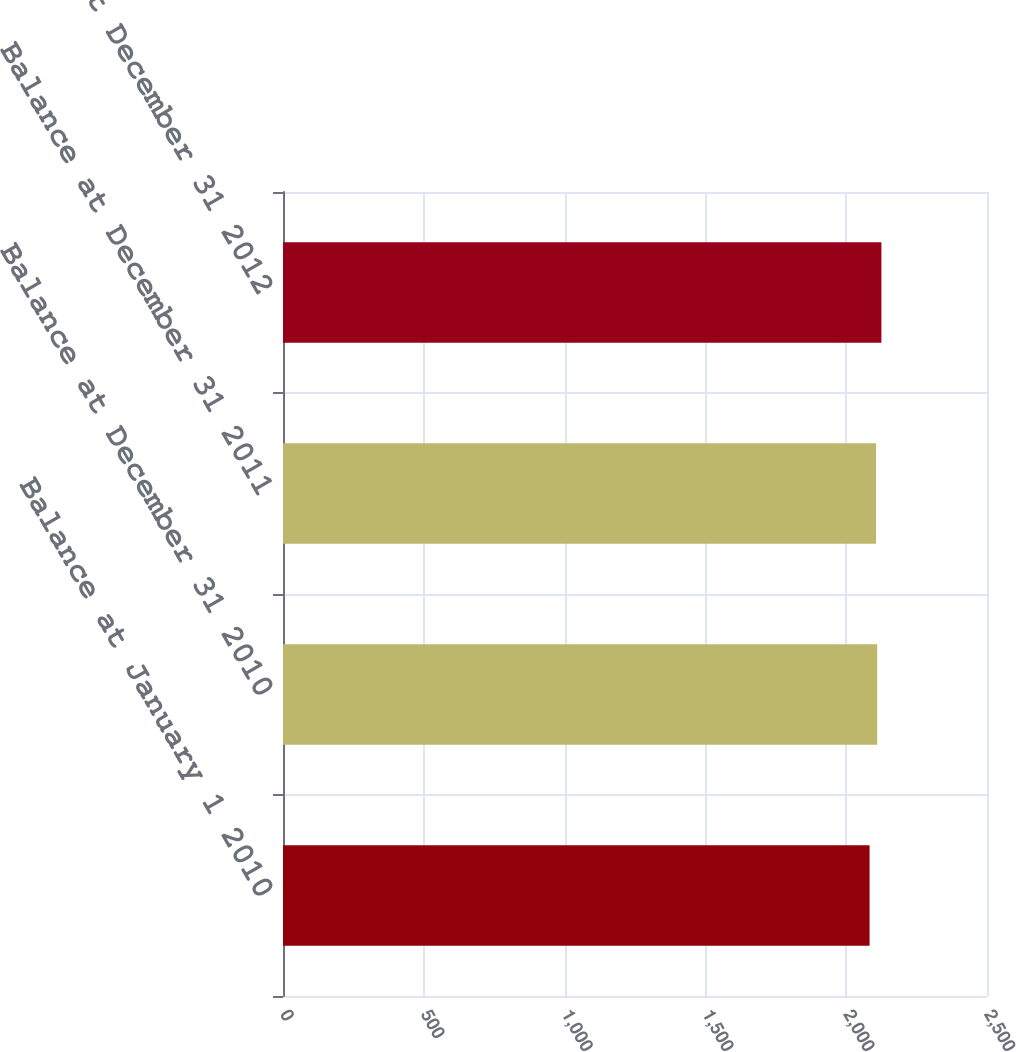<chart> <loc_0><loc_0><loc_500><loc_500><bar_chart><fcel>Balance at January 1 2010<fcel>Balance at December 31 2010<fcel>Balance at December 31 2011<fcel>Balance at December 31 2012<nl><fcel>2083<fcel>2110.2<fcel>2106<fcel>2125<nl></chart> 